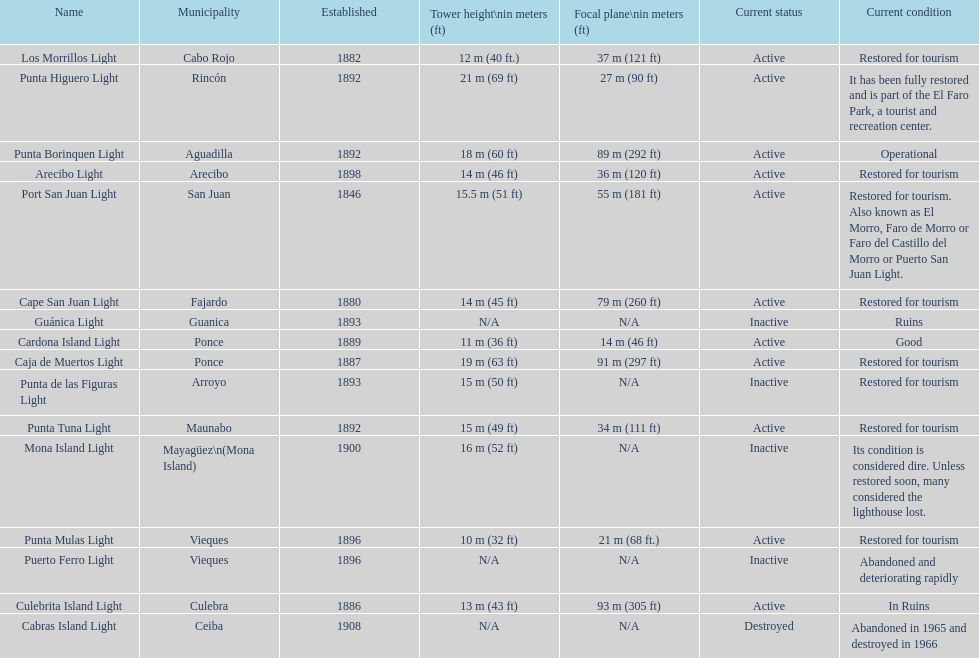Which municipality was the first to be established? San Juan. 